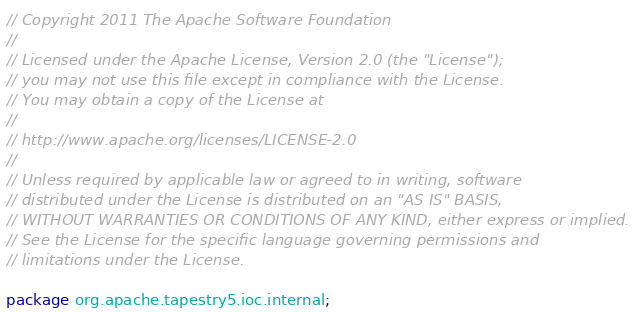Convert code to text. <code><loc_0><loc_0><loc_500><loc_500><_Java_>// Copyright 2011 The Apache Software Foundation
//
// Licensed under the Apache License, Version 2.0 (the "License");
// you may not use this file except in compliance with the License.
// You may obtain a copy of the License at
//
// http://www.apache.org/licenses/LICENSE-2.0
//
// Unless required by applicable law or agreed to in writing, software
// distributed under the License is distributed on an "AS IS" BASIS,
// WITHOUT WARRANTIES OR CONDITIONS OF ANY KIND, either express or implied.
// See the License for the specific language governing permissions and
// limitations under the License.

package org.apache.tapestry5.ioc.internal;
</code> 